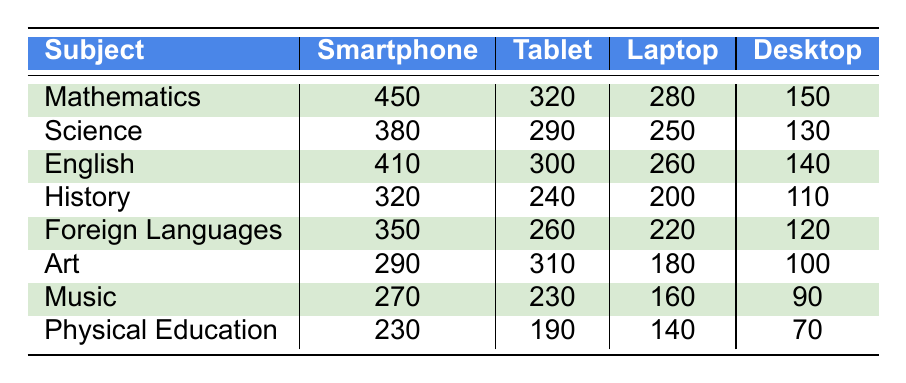What subject has the highest usage on smartphones? Looking at the smartphone column, Mathematics has the highest value at 450, compared to the other subjects.
Answer: Mathematics Which subject is least used on desktops? In the desktop column, Physical Education has the lowest usage at 70, which is less than the other subjects.
Answer: Physical Education What is the total usage of tablets across all subjects? To find the total usage of tablets, we add the values: 320 (Mathematics) + 290 (Science) + 300 (English) + 240 (History) + 260 (Foreign Languages) + 310 (Art) + 230 (Music) + 190 (Physical Education) = 2090.
Answer: 2090 Which subject has the largest difference between smartphone and desktop usage? We calculate the difference for each subject: 
- Mathematics: 450 - 150 = 300 
- Science: 380 - 130 = 250 
- English: 410 - 140 = 270 
- History: 320 - 110 = 210 
- Foreign Languages: 350 - 120 = 230 
- Art: 290 - 100 = 190 
- Music: 270 - 90 = 180 
- Physical Education: 230 - 70 = 160 
Mathematics has the largest difference of 300.
Answer: Mathematics Is more usage seen in tablets or laptops across all subjects? We will sum the values for tablets and laptops: 
Tablets: 320 + 290 + 300 + 240 + 260 + 310 + 230 + 190 = 2090 
Laptops: 280 + 250 + 260 + 200 + 220 + 180 + 160 + 140 = 1680. Since 2090 is greater than 1680, tablets have more usage.
Answer: Tablets What is the average number of smartphone users across all subjects? To find the average, we sum the smartphone values: 450 + 380 + 410 + 320 + 350 + 290 + 270 + 230 = 2250. There are 8 subjects, so the average is 2250 ÷ 8 = 281.25.
Answer: 281.25 Which subject has the highest total usage across all devices? First, we calculate the total for each subject:
- Mathematics: 450 + 320 + 280 + 150 = 1200 
- Science: 380 + 290 + 250 + 130 = 1050 
- English: 410 + 300 + 260 + 140 = 1110 
- History: 320 + 240 + 200 + 110 = 870 
- Foreign Languages: 350 + 260 + 220 + 120 = 950 
- Art: 290 + 310 + 180 + 100 = 880 
- Music: 270 + 230 + 160 + 90 = 750 
- Physical Education: 230 + 190 + 140 + 70 = 630 
Mathematics has the highest total usage of 1200.
Answer: Mathematics Is the usage of smartphones for Foreign Languages higher than that of Art? The smartphone usage for Foreign Languages is 350 and for Art is 290. Since 350 is greater than 290, the statement is true.
Answer: Yes 